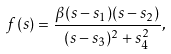<formula> <loc_0><loc_0><loc_500><loc_500>f ( s ) = \frac { \beta ( s - s _ { 1 } ) ( s - s _ { 2 } ) } { ( s - s _ { 3 } ) ^ { 2 } + s _ { 4 } ^ { 2 } } ,</formula> 